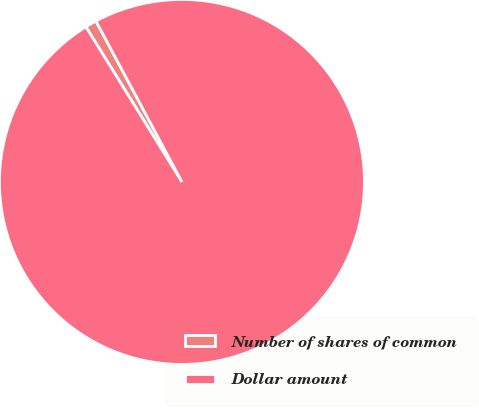Convert chart. <chart><loc_0><loc_0><loc_500><loc_500><pie_chart><fcel>Number of shares of common<fcel>Dollar amount<nl><fcel>1.01%<fcel>98.99%<nl></chart> 